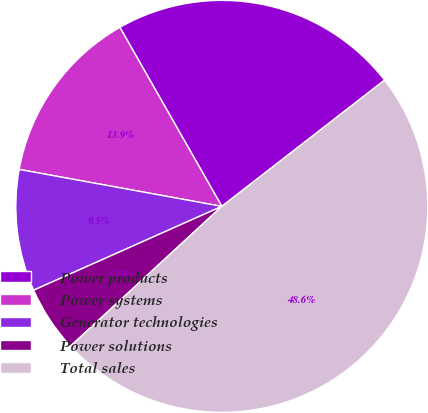<chart> <loc_0><loc_0><loc_500><loc_500><pie_chart><fcel>Power products<fcel>Power systems<fcel>Generator technologies<fcel>Power solutions<fcel>Total sales<nl><fcel>22.74%<fcel>13.89%<fcel>9.54%<fcel>5.2%<fcel>48.63%<nl></chart> 